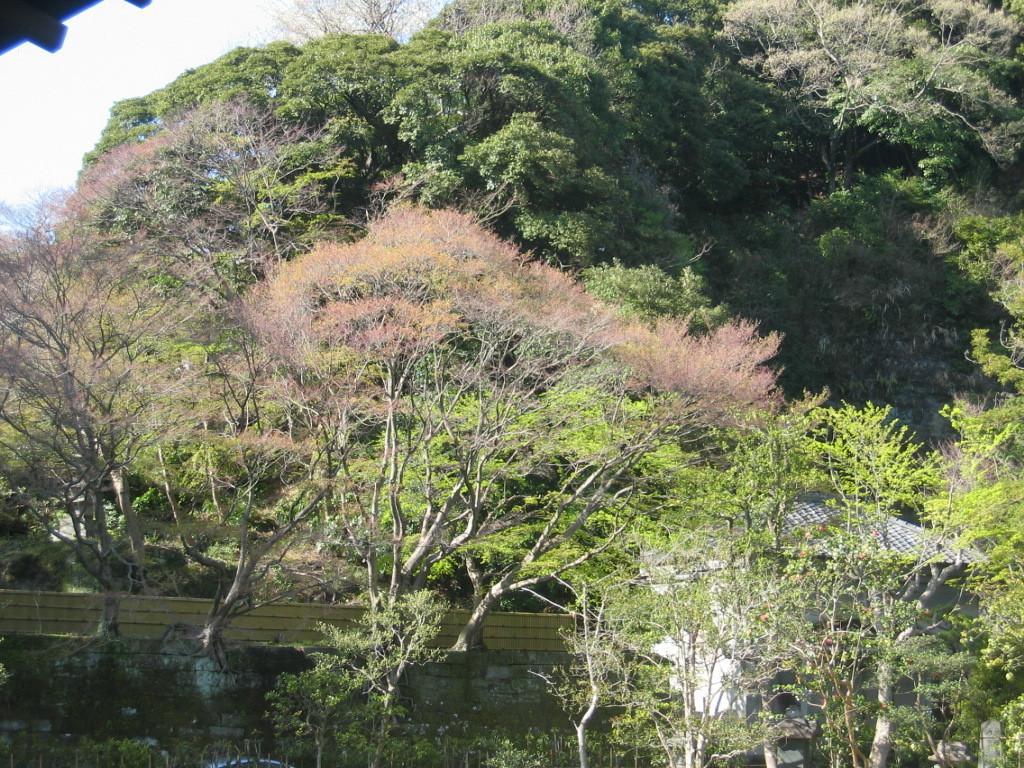How would you summarize this image in a sentence or two? In this image I can see a house, a fence and the sky in the background. 